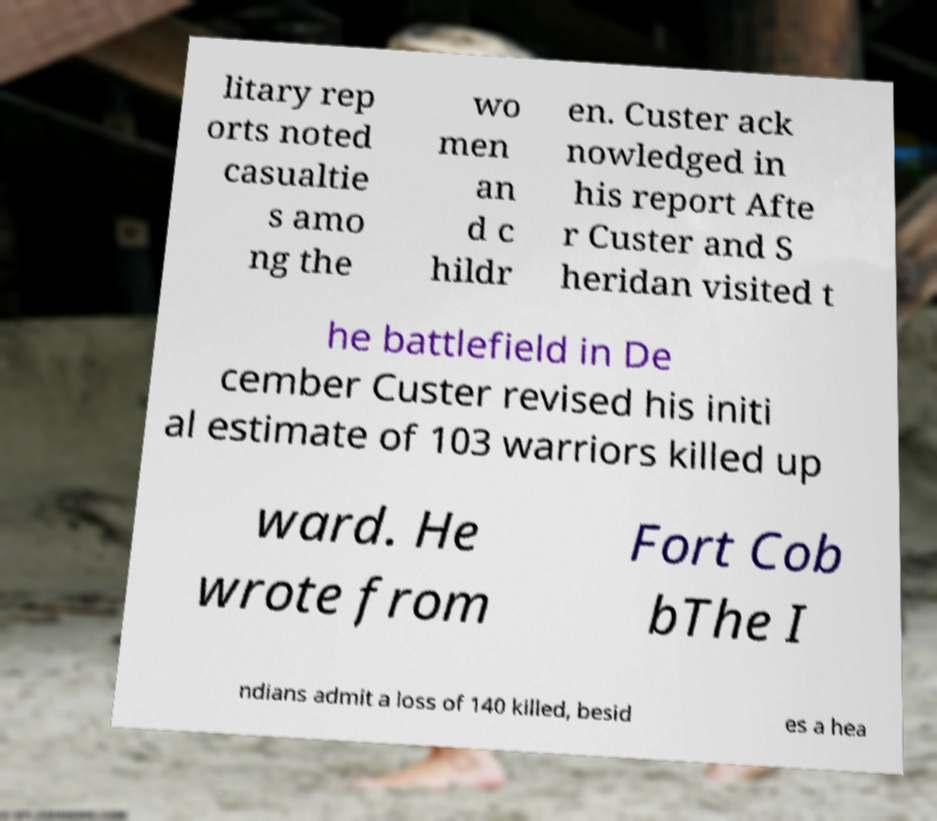Can you read and provide the text displayed in the image?This photo seems to have some interesting text. Can you extract and type it out for me? litary rep orts noted casualtie s amo ng the wo men an d c hildr en. Custer ack nowledged in his report Afte r Custer and S heridan visited t he battlefield in De cember Custer revised his initi al estimate of 103 warriors killed up ward. He wrote from Fort Cob bThe I ndians admit a loss of 140 killed, besid es a hea 